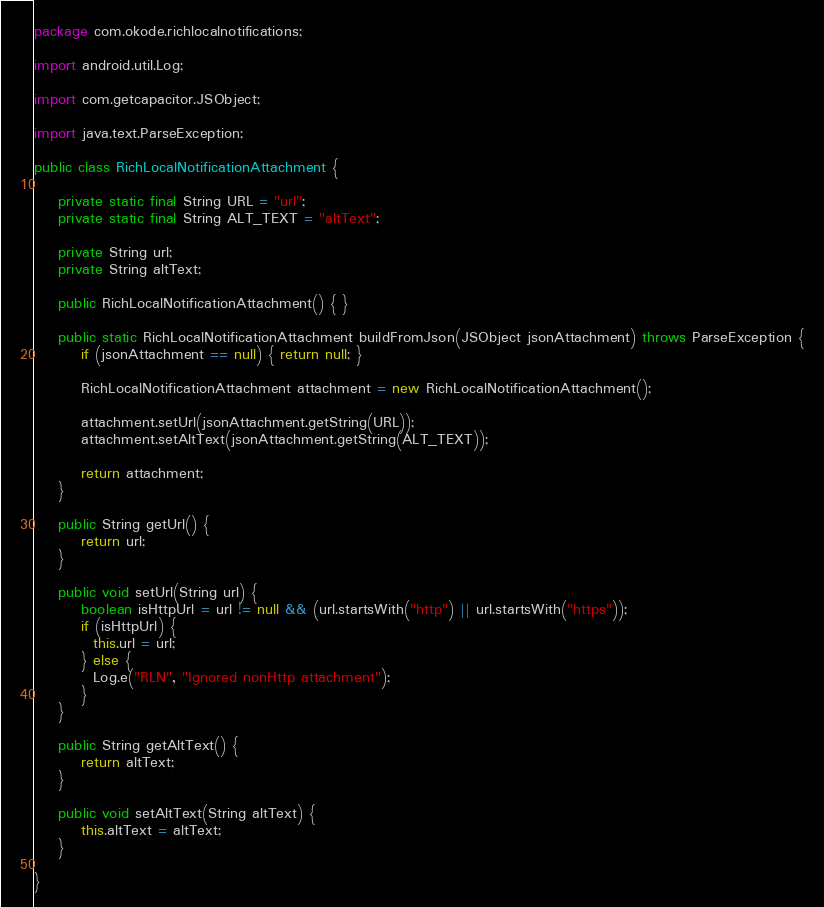Convert code to text. <code><loc_0><loc_0><loc_500><loc_500><_Java_>package com.okode.richlocalnotifications;

import android.util.Log;

import com.getcapacitor.JSObject;

import java.text.ParseException;

public class RichLocalNotificationAttachment {

    private static final String URL = "url";
    private static final String ALT_TEXT = "altText";

    private String url;
    private String altText;

    public RichLocalNotificationAttachment() { }

    public static RichLocalNotificationAttachment buildFromJson(JSObject jsonAttachment) throws ParseException {
        if (jsonAttachment == null) { return null; }

        RichLocalNotificationAttachment attachment = new RichLocalNotificationAttachment();

        attachment.setUrl(jsonAttachment.getString(URL));
        attachment.setAltText(jsonAttachment.getString(ALT_TEXT));

        return attachment;
    }

    public String getUrl() {
        return url;
    }

    public void setUrl(String url) {
        boolean isHttpUrl = url != null && (url.startsWith("http") || url.startsWith("https"));
        if (isHttpUrl) {
          this.url = url;
        } else {
          Log.e("RLN", "Ignored nonHttp attachment");
        }
    }

    public String getAltText() {
        return altText;
    }

    public void setAltText(String altText) {
        this.altText = altText;
    }

}
</code> 